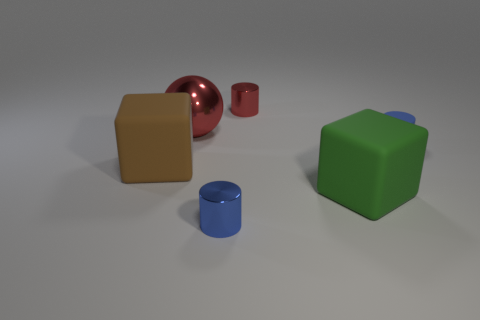How many tiny objects are either red things or metal cylinders?
Keep it short and to the point. 2. What color is the shiny ball?
Offer a terse response. Red. There is a tiny object that is behind the blue object that is to the right of the big green thing; what is its shape?
Keep it short and to the point. Cylinder. Are there any green cubes made of the same material as the red sphere?
Your answer should be compact. No. There is a cylinder that is in front of the brown rubber thing; is it the same size as the tiny red thing?
Keep it short and to the point. Yes. What number of cyan objects are either small things or large metal balls?
Make the answer very short. 0. There is a tiny object in front of the large brown cube; what material is it?
Make the answer very short. Metal. There is a big rubber object left of the big red ball; how many large red metallic balls are right of it?
Your answer should be very brief. 1. How many other red things are the same shape as the small matte thing?
Your answer should be very brief. 1. How many blue shiny objects are there?
Your answer should be compact. 1. 